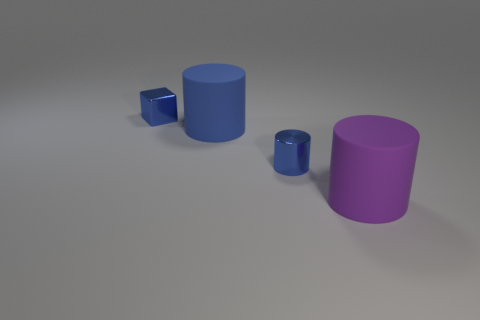Add 1 purple cylinders. How many objects exist? 5 Subtract all cubes. How many objects are left? 3 Subtract all small red rubber objects. Subtract all rubber cylinders. How many objects are left? 2 Add 1 big things. How many big things are left? 3 Add 4 big blue matte objects. How many big blue matte objects exist? 5 Subtract 0 yellow spheres. How many objects are left? 4 